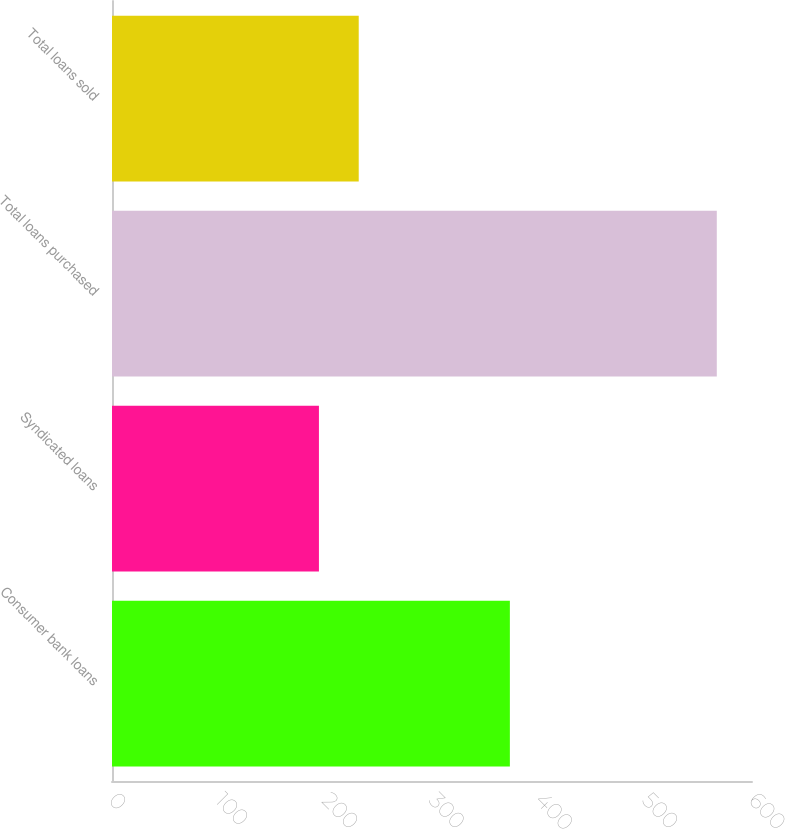<chart> <loc_0><loc_0><loc_500><loc_500><bar_chart><fcel>Consumer bank loans<fcel>Syndicated loans<fcel>Total loans purchased<fcel>Total loans sold<nl><fcel>373<fcel>194<fcel>567<fcel>231.3<nl></chart> 